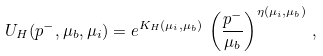Convert formula to latex. <formula><loc_0><loc_0><loc_500><loc_500>U _ { H } ( p ^ { - } , \mu _ { b } , \mu _ { i } ) = e ^ { K _ { H } ( \mu _ { i } , \mu _ { b } ) } \, \left ( \frac { p ^ { - } } { \mu _ { b } } \right ) ^ { \eta ( \mu _ { i } , \mu _ { b } ) } \, ,</formula> 